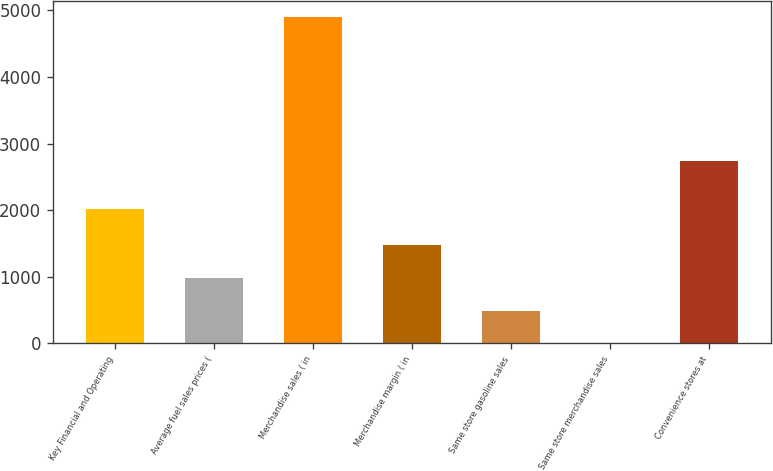<chart> <loc_0><loc_0><loc_500><loc_500><bar_chart><fcel>Key Financial and Operating<fcel>Average fuel sales prices (<fcel>Merchandise sales ( in<fcel>Merchandise margin ( in<fcel>Same store gasoline sales<fcel>Same store merchandise sales<fcel>Convenience stores at<nl><fcel>2017<fcel>979.56<fcel>4893<fcel>1468.74<fcel>490.38<fcel>1.2<fcel>2744<nl></chart> 